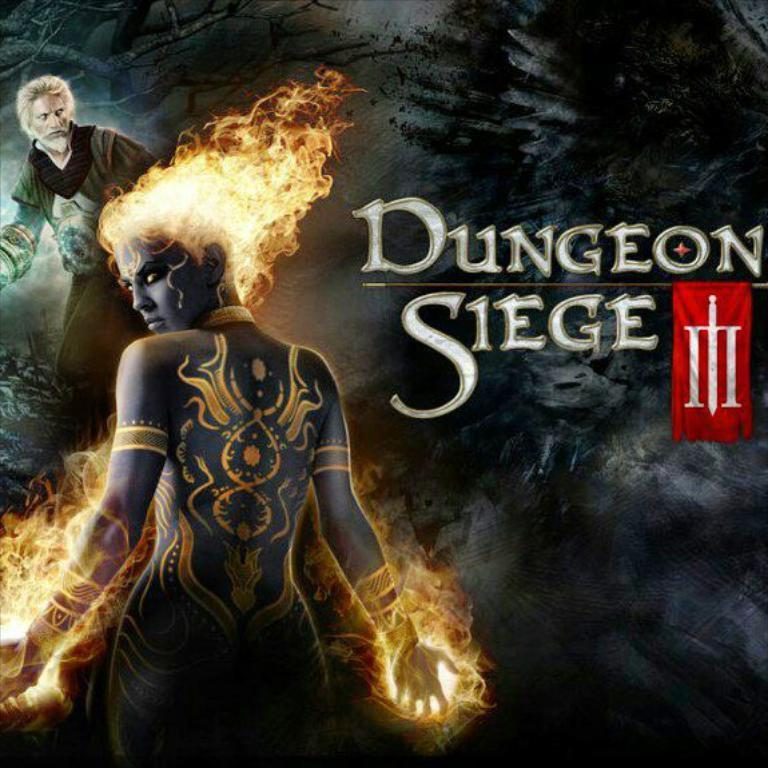What is the main subject of the image? There is a person standing in the image. Can you describe the person in the background? There is another person in the background of the image, and they are wearing a black jacket. What can be seen on the black jacket? There is something written on the black jacket. What type of bait is the person in the foreground using to catch fish in the image? There is no indication of fishing or bait in the image; it features two people and a jacket with writing. Does the existence of the person in the background prove the existence of extraterrestrial life in the image? The image does not provide any information about extraterrestrial life, and the presence of the person in the background is not related to this topic. 